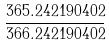Convert formula to latex. <formula><loc_0><loc_0><loc_500><loc_500>\frac { 3 6 5 . 2 4 2 1 9 0 4 0 2 } { 3 6 6 . 2 4 2 1 9 0 4 0 2 }</formula> 